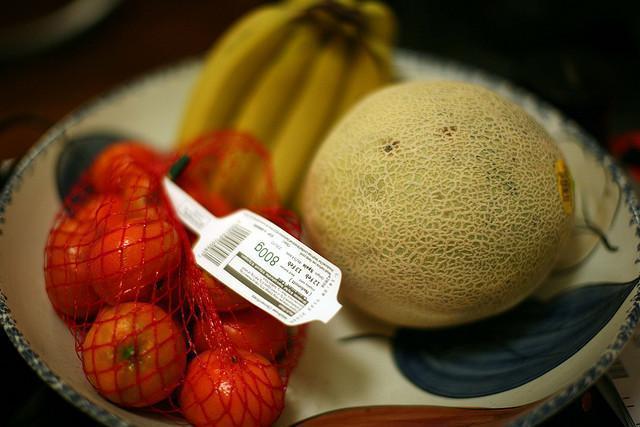How many bananas can be seen?
Give a very brief answer. 1. How many oranges can be seen?
Give a very brief answer. 5. 